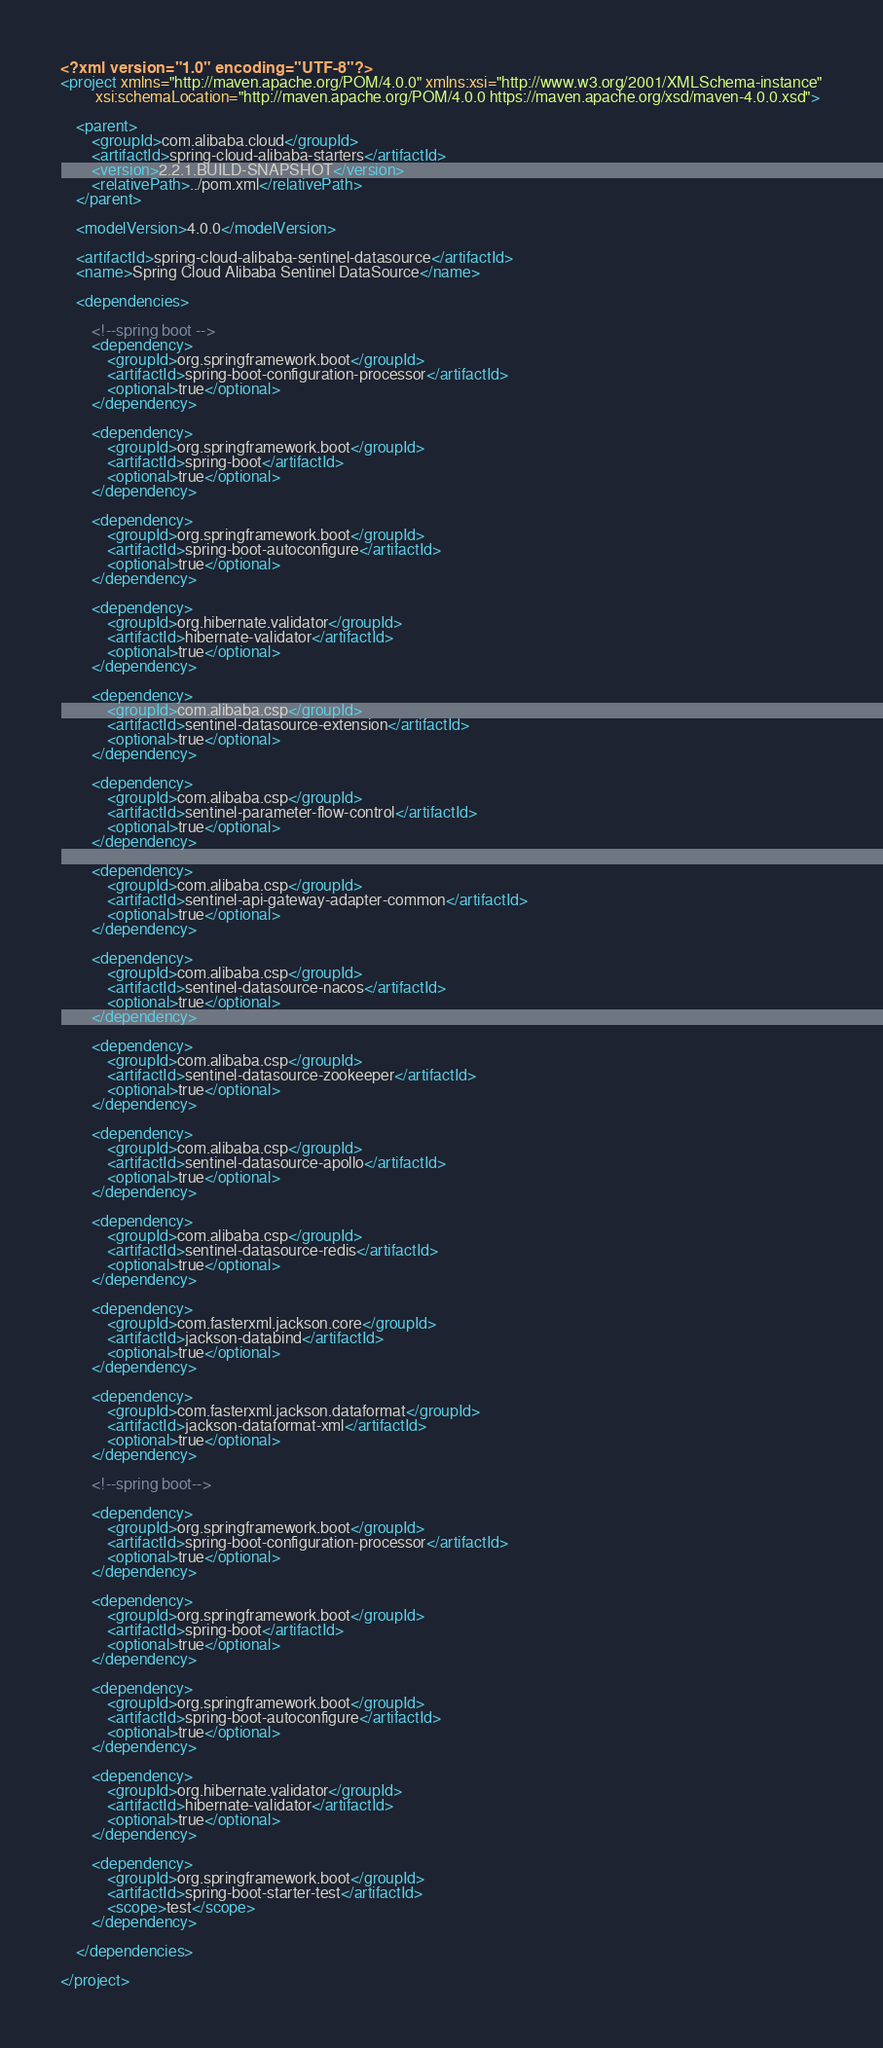<code> <loc_0><loc_0><loc_500><loc_500><_XML_><?xml version="1.0" encoding="UTF-8"?>
<project xmlns="http://maven.apache.org/POM/4.0.0" xmlns:xsi="http://www.w3.org/2001/XMLSchema-instance"
         xsi:schemaLocation="http://maven.apache.org/POM/4.0.0 https://maven.apache.org/xsd/maven-4.0.0.xsd">

    <parent>
        <groupId>com.alibaba.cloud</groupId>
        <artifactId>spring-cloud-alibaba-starters</artifactId>
        <version>2.2.1.BUILD-SNAPSHOT</version>
        <relativePath>../pom.xml</relativePath>
    </parent>

    <modelVersion>4.0.0</modelVersion>

    <artifactId>spring-cloud-alibaba-sentinel-datasource</artifactId>
    <name>Spring Cloud Alibaba Sentinel DataSource</name>

    <dependencies>

        <!--spring boot -->
        <dependency>
            <groupId>org.springframework.boot</groupId>
            <artifactId>spring-boot-configuration-processor</artifactId>
            <optional>true</optional>
        </dependency>

        <dependency>
            <groupId>org.springframework.boot</groupId>
            <artifactId>spring-boot</artifactId>
            <optional>true</optional>
        </dependency>

        <dependency>
            <groupId>org.springframework.boot</groupId>
            <artifactId>spring-boot-autoconfigure</artifactId>
            <optional>true</optional>
        </dependency>

        <dependency>
            <groupId>org.hibernate.validator</groupId>
            <artifactId>hibernate-validator</artifactId>
            <optional>true</optional>
        </dependency>

        <dependency>
            <groupId>com.alibaba.csp</groupId>
            <artifactId>sentinel-datasource-extension</artifactId>
            <optional>true</optional>
        </dependency>

        <dependency>
            <groupId>com.alibaba.csp</groupId>
            <artifactId>sentinel-parameter-flow-control</artifactId>
            <optional>true</optional>
        </dependency>

        <dependency>
            <groupId>com.alibaba.csp</groupId>
            <artifactId>sentinel-api-gateway-adapter-common</artifactId>
            <optional>true</optional>
        </dependency>

        <dependency>
            <groupId>com.alibaba.csp</groupId>
            <artifactId>sentinel-datasource-nacos</artifactId>
            <optional>true</optional>
        </dependency>

        <dependency>
            <groupId>com.alibaba.csp</groupId>
            <artifactId>sentinel-datasource-zookeeper</artifactId>
            <optional>true</optional>
        </dependency>

        <dependency>
            <groupId>com.alibaba.csp</groupId>
            <artifactId>sentinel-datasource-apollo</artifactId>
            <optional>true</optional>
        </dependency>

        <dependency>
            <groupId>com.alibaba.csp</groupId>
            <artifactId>sentinel-datasource-redis</artifactId>
            <optional>true</optional>
        </dependency>

        <dependency>
            <groupId>com.fasterxml.jackson.core</groupId>
            <artifactId>jackson-databind</artifactId>
            <optional>true</optional>
        </dependency>

        <dependency>
            <groupId>com.fasterxml.jackson.dataformat</groupId>
            <artifactId>jackson-dataformat-xml</artifactId>
            <optional>true</optional>
        </dependency>

        <!--spring boot-->

        <dependency>
            <groupId>org.springframework.boot</groupId>
            <artifactId>spring-boot-configuration-processor</artifactId>
            <optional>true</optional>
        </dependency>

        <dependency>
            <groupId>org.springframework.boot</groupId>
            <artifactId>spring-boot</artifactId>
            <optional>true</optional>
        </dependency>

        <dependency>
            <groupId>org.springframework.boot</groupId>
            <artifactId>spring-boot-autoconfigure</artifactId>
            <optional>true</optional>
        </dependency>

        <dependency>
            <groupId>org.hibernate.validator</groupId>
            <artifactId>hibernate-validator</artifactId>
            <optional>true</optional>
        </dependency>

        <dependency>
            <groupId>org.springframework.boot</groupId>
            <artifactId>spring-boot-starter-test</artifactId>
            <scope>test</scope>
        </dependency>

    </dependencies>

</project>
</code> 